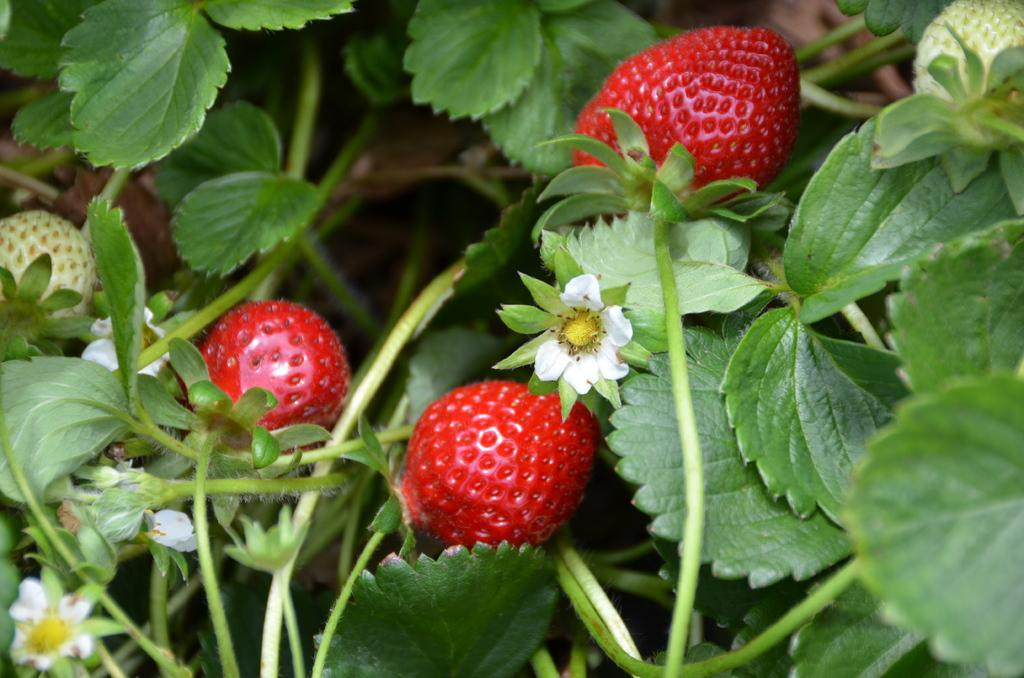What type of plant can be seen in the image? There is a tree in the image. What is the color of the tree? The tree is green in color. What types of flowers are on the tree? There are yellow and white flowers on the tree. What colors of fruits are on the tree? There are green, cream, and red fruits on the tree. What type of bulb is used to light up the cemetery in the image? There is no cemetery or bulb present in the image; it features a tree with flowers and fruits. 